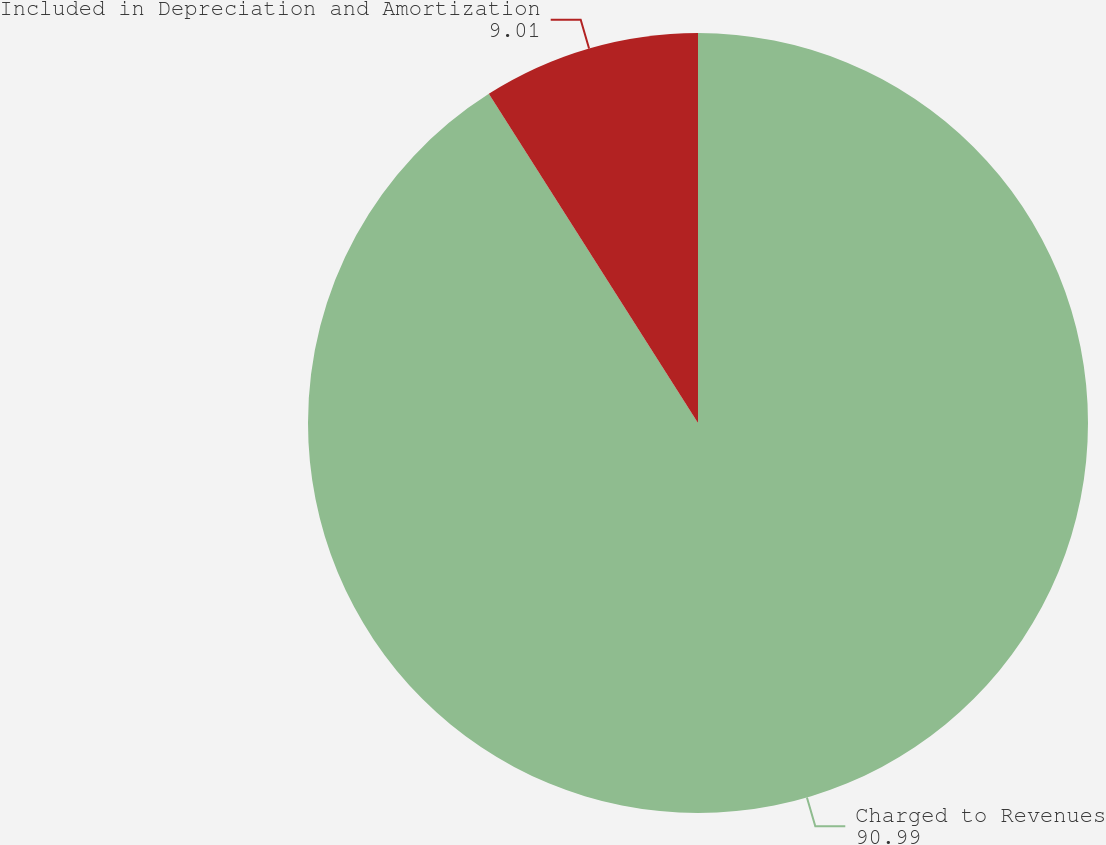Convert chart to OTSL. <chart><loc_0><loc_0><loc_500><loc_500><pie_chart><fcel>Charged to Revenues<fcel>Included in Depreciation and Amortization<nl><fcel>90.99%<fcel>9.01%<nl></chart> 